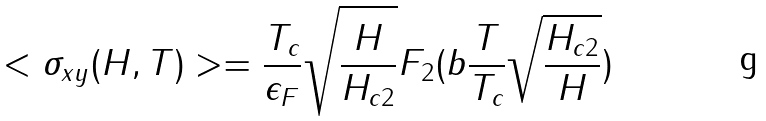Convert formula to latex. <formula><loc_0><loc_0><loc_500><loc_500>< \sigma _ { x y } ( H , T ) > = \frac { T _ { c } } { \epsilon _ { F } } \sqrt { \frac { H } { H _ { c 2 } } } F _ { 2 } ( b \frac { T } { T _ { c } } \sqrt { \frac { H _ { c 2 } } { H } } )</formula> 